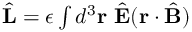Convert formula to latex. <formula><loc_0><loc_0><loc_500><loc_500>\begin{array} { r } { \hat { L } = \epsilon \int d ^ { 3 } { r } \ \hat { E } ( { r } \cdot \hat { B } ) } \end{array}</formula> 